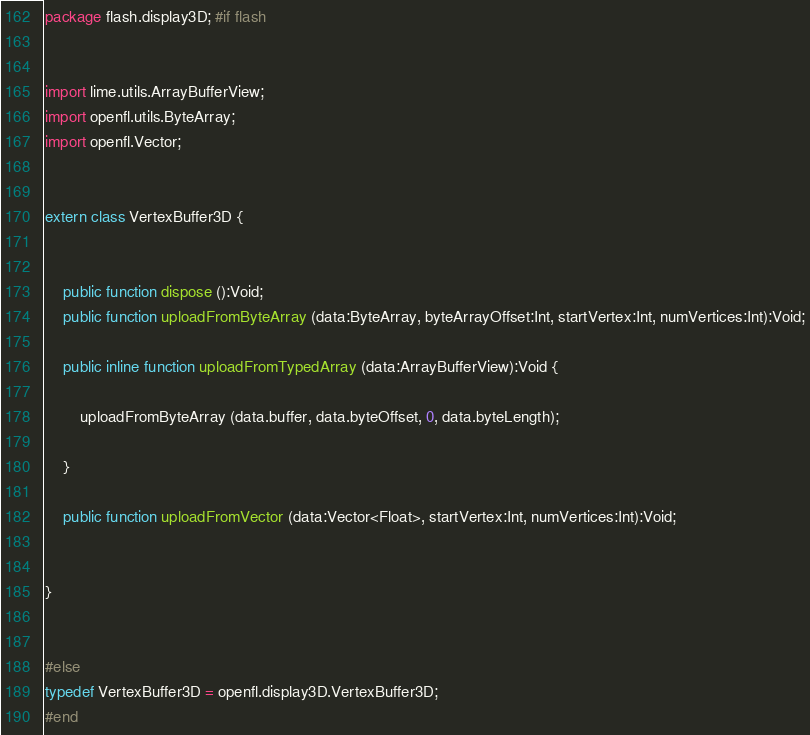Convert code to text. <code><loc_0><loc_0><loc_500><loc_500><_Haxe_>package flash.display3D; #if flash


import lime.utils.ArrayBufferView;
import openfl.utils.ByteArray;
import openfl.Vector;


extern class VertexBuffer3D {
	
	
	public function dispose ():Void;
	public function uploadFromByteArray (data:ByteArray, byteArrayOffset:Int, startVertex:Int, numVertices:Int):Void;
	
	public inline function uploadFromTypedArray (data:ArrayBufferView):Void {
		
		uploadFromByteArray (data.buffer, data.byteOffset, 0, data.byteLength);
		
	}
	
	public function uploadFromVector (data:Vector<Float>, startVertex:Int, numVertices:Int):Void;
	
	
}


#else
typedef VertexBuffer3D = openfl.display3D.VertexBuffer3D;
#end</code> 